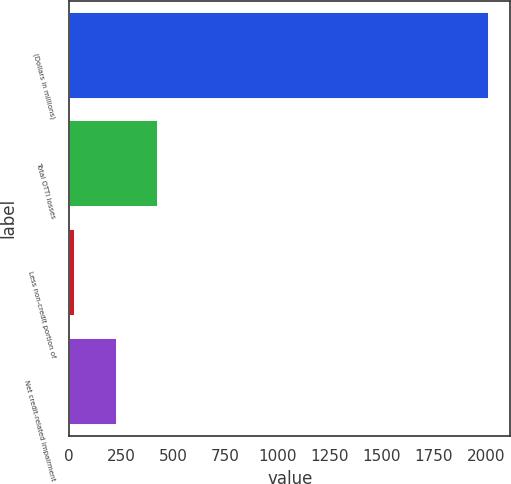Convert chart. <chart><loc_0><loc_0><loc_500><loc_500><bar_chart><fcel>(Dollars in millions)<fcel>Total OTTI losses<fcel>Less non-credit portion of<fcel>Net credit-related impairment<nl><fcel>2015<fcel>427<fcel>30<fcel>228.5<nl></chart> 